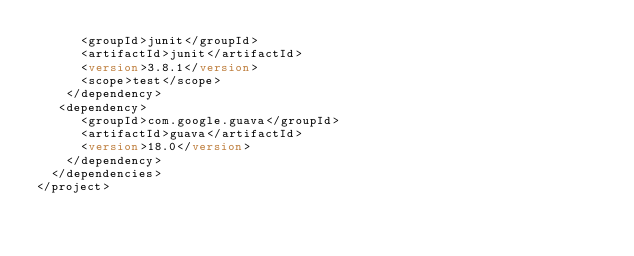<code> <loc_0><loc_0><loc_500><loc_500><_XML_>      <groupId>junit</groupId>
      <artifactId>junit</artifactId>
      <version>3.8.1</version>
      <scope>test</scope>
    </dependency>
   <dependency>
      <groupId>com.google.guava</groupId>
      <artifactId>guava</artifactId>
      <version>18.0</version>
    </dependency>
  </dependencies>
</project>
</code> 